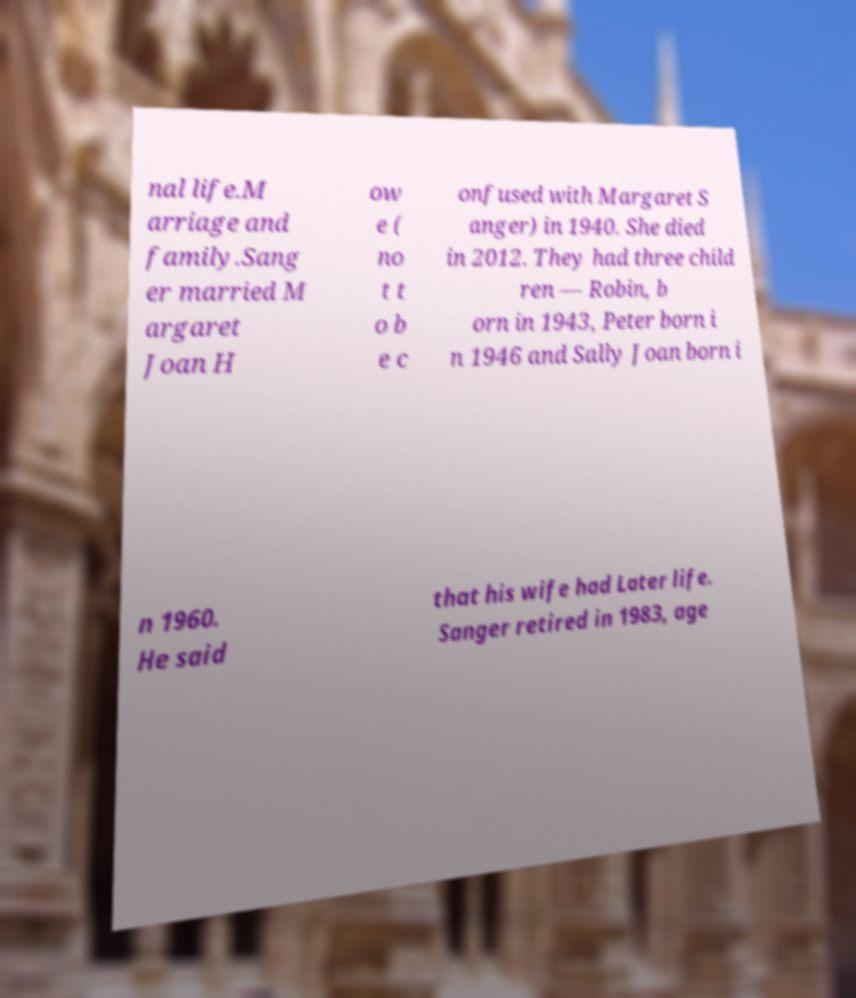Please identify and transcribe the text found in this image. nal life.M arriage and family.Sang er married M argaret Joan H ow e ( no t t o b e c onfused with Margaret S anger) in 1940. She died in 2012. They had three child ren — Robin, b orn in 1943, Peter born i n 1946 and Sally Joan born i n 1960. He said that his wife had Later life. Sanger retired in 1983, age 